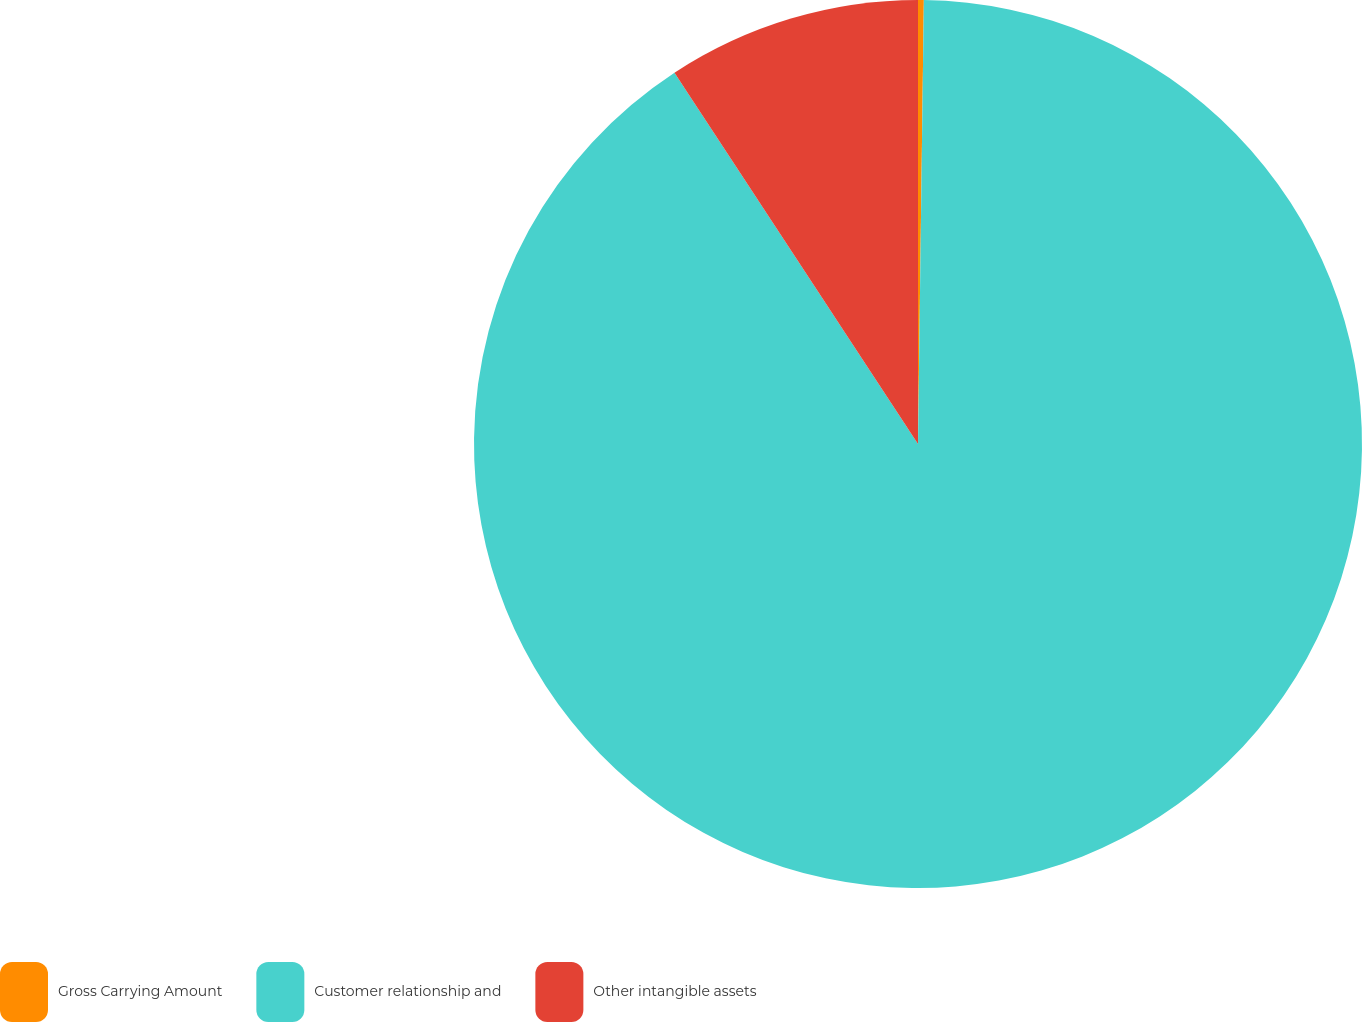<chart> <loc_0><loc_0><loc_500><loc_500><pie_chart><fcel>Gross Carrying Amount<fcel>Customer relationship and<fcel>Other intangible assets<nl><fcel>0.21%<fcel>90.55%<fcel>9.24%<nl></chart> 